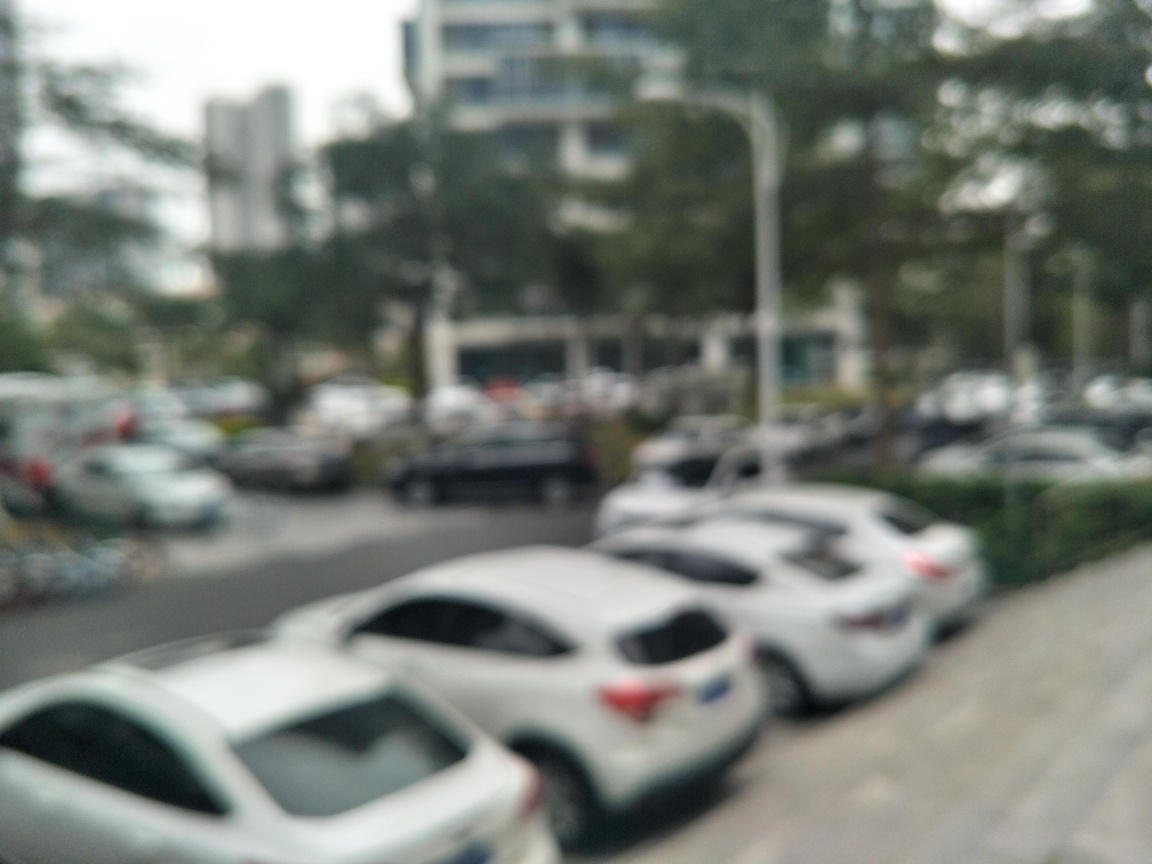Can you tell what type of vehicles are in the image? Due to the image being out of focus, it's difficult to identify the specific types of vehicles. However, they appear to be passenger cars commonly seen in urban settings. 